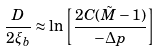Convert formula to latex. <formula><loc_0><loc_0><loc_500><loc_500>\frac { D } { 2 \xi _ { b } } \approx \ln \left [ \frac { 2 C ( \tilde { M } - 1 ) } { - \Delta p } \right ]</formula> 